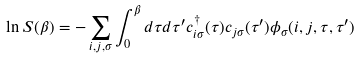Convert formula to latex. <formula><loc_0><loc_0><loc_500><loc_500>\ln S ( \beta ) = - \sum _ { i , j , \sigma } \int _ { 0 } ^ { \beta } d \tau d \tau ^ { \prime } c _ { i \sigma } ^ { \dagger } ( \tau ) c _ { j \sigma } ( \tau ^ { \prime } ) \phi _ { \sigma } ( i , j , \tau , \tau ^ { \prime } )</formula> 